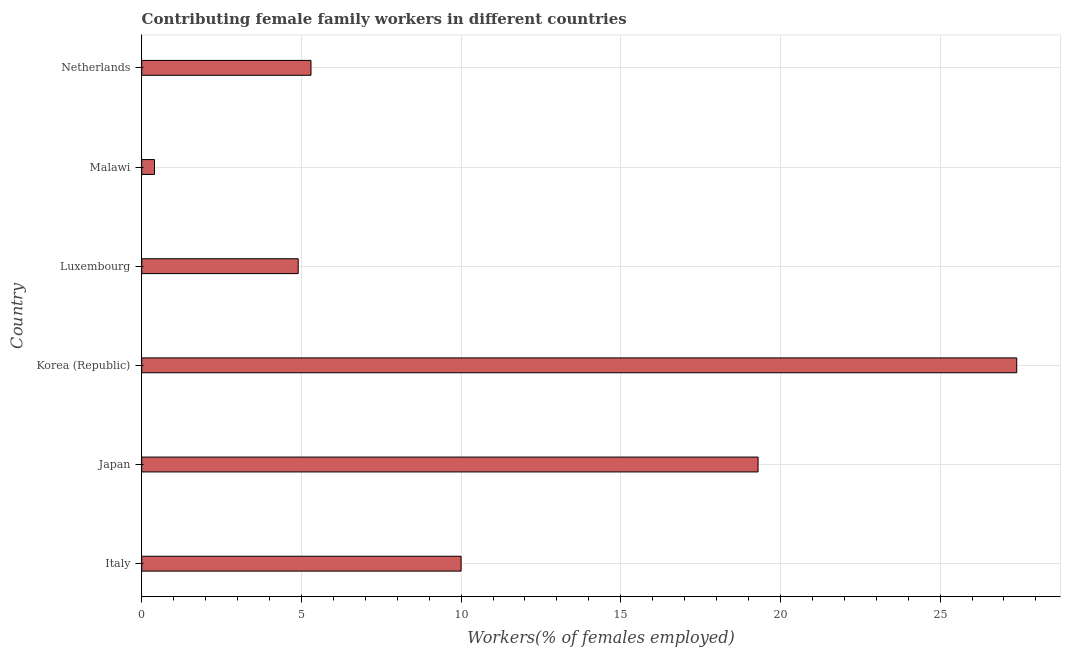What is the title of the graph?
Your answer should be very brief. Contributing female family workers in different countries. What is the label or title of the X-axis?
Offer a very short reply. Workers(% of females employed). What is the contributing female family workers in Japan?
Ensure brevity in your answer.  19.3. Across all countries, what is the maximum contributing female family workers?
Offer a terse response. 27.4. Across all countries, what is the minimum contributing female family workers?
Give a very brief answer. 0.4. In which country was the contributing female family workers maximum?
Offer a very short reply. Korea (Republic). In which country was the contributing female family workers minimum?
Offer a very short reply. Malawi. What is the sum of the contributing female family workers?
Provide a short and direct response. 67.3. What is the difference between the contributing female family workers in Korea (Republic) and Malawi?
Your answer should be compact. 27. What is the average contributing female family workers per country?
Offer a terse response. 11.22. What is the median contributing female family workers?
Your answer should be very brief. 7.65. In how many countries, is the contributing female family workers greater than 9 %?
Offer a terse response. 3. What is the ratio of the contributing female family workers in Japan to that in Malawi?
Offer a terse response. 48.25. Is the difference between the contributing female family workers in Italy and Malawi greater than the difference between any two countries?
Provide a succinct answer. No. What is the difference between the highest and the second highest contributing female family workers?
Your answer should be very brief. 8.1. Are the values on the major ticks of X-axis written in scientific E-notation?
Your answer should be compact. No. What is the Workers(% of females employed) of Japan?
Offer a terse response. 19.3. What is the Workers(% of females employed) in Korea (Republic)?
Offer a very short reply. 27.4. What is the Workers(% of females employed) of Luxembourg?
Provide a short and direct response. 4.9. What is the Workers(% of females employed) of Malawi?
Make the answer very short. 0.4. What is the Workers(% of females employed) of Netherlands?
Keep it short and to the point. 5.3. What is the difference between the Workers(% of females employed) in Italy and Korea (Republic)?
Ensure brevity in your answer.  -17.4. What is the difference between the Workers(% of females employed) in Italy and Luxembourg?
Provide a succinct answer. 5.1. What is the difference between the Workers(% of females employed) in Italy and Malawi?
Offer a terse response. 9.6. What is the difference between the Workers(% of females employed) in Japan and Korea (Republic)?
Your answer should be compact. -8.1. What is the difference between the Workers(% of females employed) in Japan and Malawi?
Your response must be concise. 18.9. What is the difference between the Workers(% of females employed) in Korea (Republic) and Netherlands?
Ensure brevity in your answer.  22.1. What is the difference between the Workers(% of females employed) in Luxembourg and Malawi?
Offer a terse response. 4.5. What is the difference between the Workers(% of females employed) in Luxembourg and Netherlands?
Ensure brevity in your answer.  -0.4. What is the difference between the Workers(% of females employed) in Malawi and Netherlands?
Offer a terse response. -4.9. What is the ratio of the Workers(% of females employed) in Italy to that in Japan?
Your answer should be compact. 0.52. What is the ratio of the Workers(% of females employed) in Italy to that in Korea (Republic)?
Provide a short and direct response. 0.36. What is the ratio of the Workers(% of females employed) in Italy to that in Luxembourg?
Your answer should be very brief. 2.04. What is the ratio of the Workers(% of females employed) in Italy to that in Netherlands?
Your response must be concise. 1.89. What is the ratio of the Workers(% of females employed) in Japan to that in Korea (Republic)?
Offer a terse response. 0.7. What is the ratio of the Workers(% of females employed) in Japan to that in Luxembourg?
Your response must be concise. 3.94. What is the ratio of the Workers(% of females employed) in Japan to that in Malawi?
Your response must be concise. 48.25. What is the ratio of the Workers(% of females employed) in Japan to that in Netherlands?
Keep it short and to the point. 3.64. What is the ratio of the Workers(% of females employed) in Korea (Republic) to that in Luxembourg?
Your response must be concise. 5.59. What is the ratio of the Workers(% of females employed) in Korea (Republic) to that in Malawi?
Offer a very short reply. 68.5. What is the ratio of the Workers(% of females employed) in Korea (Republic) to that in Netherlands?
Your response must be concise. 5.17. What is the ratio of the Workers(% of females employed) in Luxembourg to that in Malawi?
Give a very brief answer. 12.25. What is the ratio of the Workers(% of females employed) in Luxembourg to that in Netherlands?
Your response must be concise. 0.93. What is the ratio of the Workers(% of females employed) in Malawi to that in Netherlands?
Give a very brief answer. 0.07. 